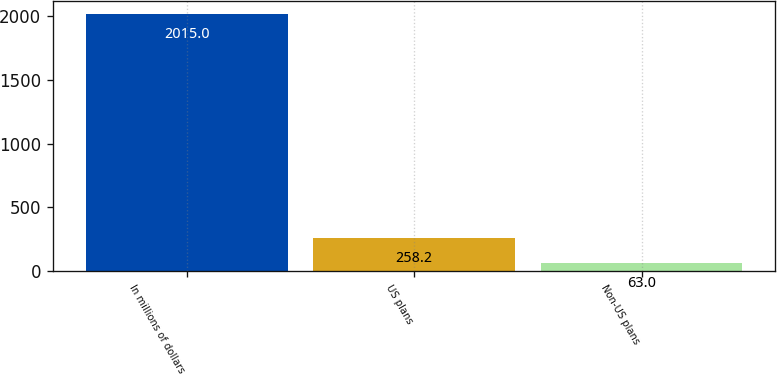<chart> <loc_0><loc_0><loc_500><loc_500><bar_chart><fcel>In millions of dollars<fcel>US plans<fcel>Non-US plans<nl><fcel>2015<fcel>258.2<fcel>63<nl></chart> 